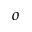<formula> <loc_0><loc_0><loc_500><loc_500>^ { o }</formula> 